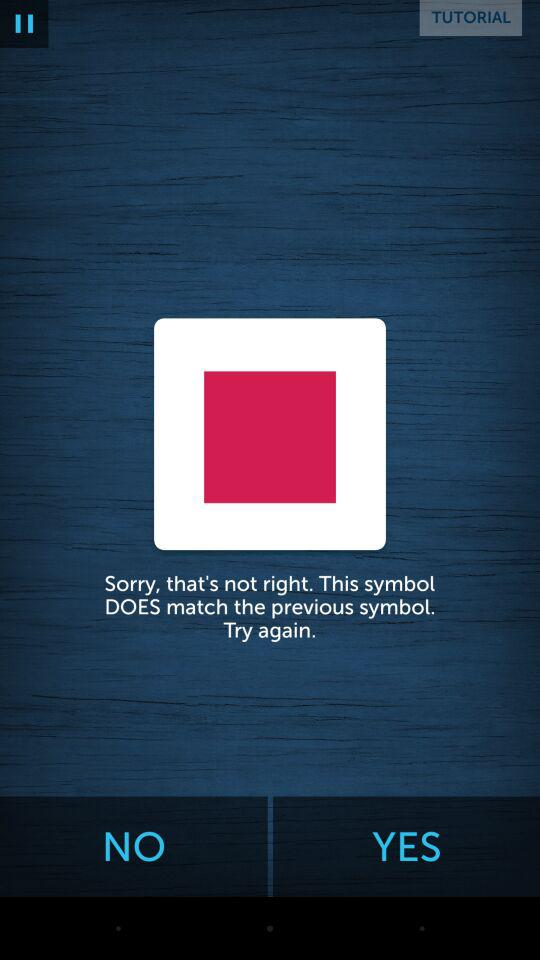What accounts can I use to sign up? The accounts that can be used to sign up are "Facebook" and "Email". 